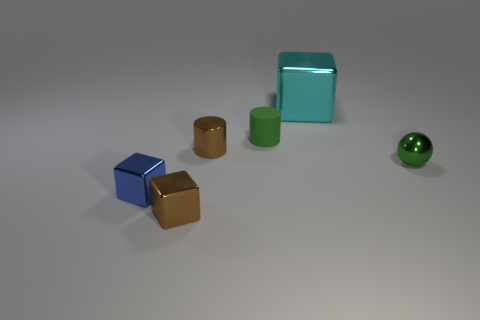How many tiny brown cylinders have the same material as the small green sphere?
Your answer should be very brief. 1. There is a shiny thing behind the tiny green cylinder; does it have the same size as the green object in front of the green rubber cylinder?
Your answer should be very brief. No. What is the material of the small green thing that is on the right side of the big thing behind the blue shiny object?
Your answer should be compact. Metal. Are there fewer things that are in front of the tiny blue shiny thing than metal cylinders that are on the left side of the small green matte cylinder?
Offer a very short reply. No. There is a thing that is the same color as the tiny metal ball; what is its material?
Offer a terse response. Rubber. Is there anything else that is the same shape as the large cyan shiny thing?
Keep it short and to the point. Yes. What material is the green thing that is on the left side of the cyan cube?
Provide a short and direct response. Rubber. Are there any other things that are the same size as the cyan block?
Your answer should be very brief. No. Are there any matte things on the right side of the metallic sphere?
Ensure brevity in your answer.  No. What is the shape of the blue metal object?
Your response must be concise. Cube. 